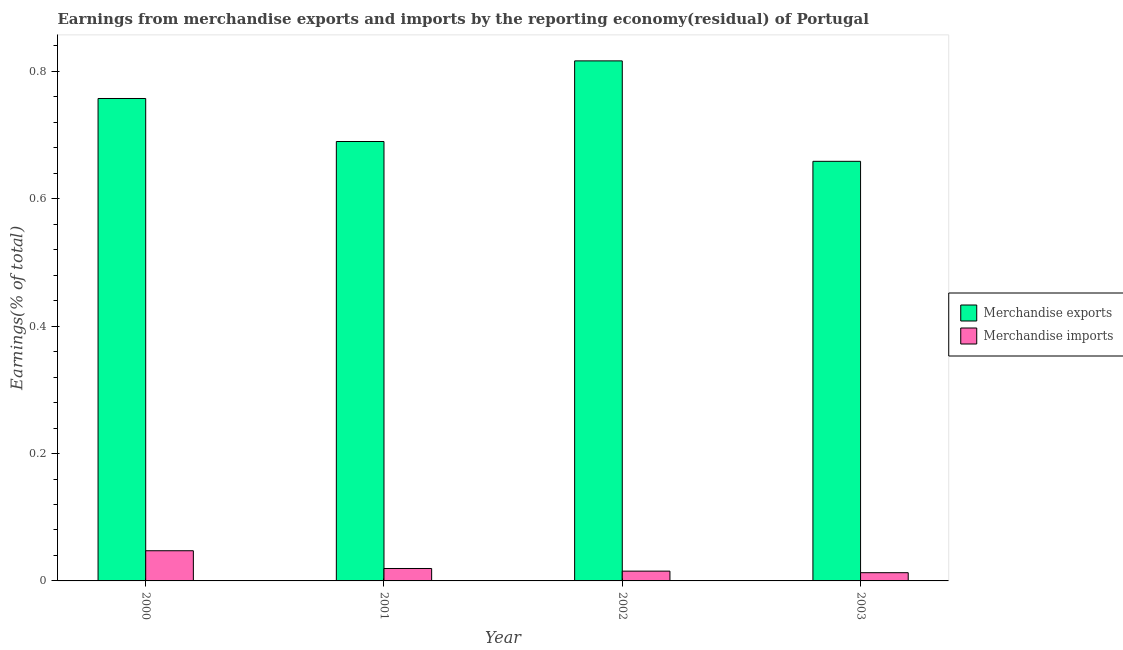How many different coloured bars are there?
Provide a short and direct response. 2. In how many cases, is the number of bars for a given year not equal to the number of legend labels?
Offer a terse response. 0. What is the earnings from merchandise exports in 2001?
Ensure brevity in your answer.  0.69. Across all years, what is the maximum earnings from merchandise exports?
Your answer should be very brief. 0.82. Across all years, what is the minimum earnings from merchandise exports?
Your response must be concise. 0.66. In which year was the earnings from merchandise imports maximum?
Ensure brevity in your answer.  2000. What is the total earnings from merchandise exports in the graph?
Offer a terse response. 2.92. What is the difference between the earnings from merchandise exports in 2000 and that in 2001?
Provide a succinct answer. 0.07. What is the difference between the earnings from merchandise exports in 2003 and the earnings from merchandise imports in 2002?
Give a very brief answer. -0.16. What is the average earnings from merchandise imports per year?
Keep it short and to the point. 0.02. In the year 2002, what is the difference between the earnings from merchandise imports and earnings from merchandise exports?
Offer a very short reply. 0. What is the ratio of the earnings from merchandise exports in 2000 to that in 2002?
Ensure brevity in your answer.  0.93. Is the earnings from merchandise imports in 2002 less than that in 2003?
Offer a very short reply. No. Is the difference between the earnings from merchandise exports in 2001 and 2002 greater than the difference between the earnings from merchandise imports in 2001 and 2002?
Make the answer very short. No. What is the difference between the highest and the second highest earnings from merchandise exports?
Provide a succinct answer. 0.06. What is the difference between the highest and the lowest earnings from merchandise exports?
Ensure brevity in your answer.  0.16. Is the sum of the earnings from merchandise imports in 2000 and 2001 greater than the maximum earnings from merchandise exports across all years?
Offer a terse response. Yes. What does the 2nd bar from the right in 2001 represents?
Your answer should be very brief. Merchandise exports. How are the legend labels stacked?
Provide a succinct answer. Vertical. What is the title of the graph?
Give a very brief answer. Earnings from merchandise exports and imports by the reporting economy(residual) of Portugal. Does "Passenger Transport Items" appear as one of the legend labels in the graph?
Ensure brevity in your answer.  No. What is the label or title of the X-axis?
Offer a very short reply. Year. What is the label or title of the Y-axis?
Make the answer very short. Earnings(% of total). What is the Earnings(% of total) in Merchandise exports in 2000?
Offer a very short reply. 0.76. What is the Earnings(% of total) of Merchandise imports in 2000?
Provide a short and direct response. 0.05. What is the Earnings(% of total) of Merchandise exports in 2001?
Your answer should be very brief. 0.69. What is the Earnings(% of total) of Merchandise imports in 2001?
Offer a terse response. 0.02. What is the Earnings(% of total) in Merchandise exports in 2002?
Ensure brevity in your answer.  0.82. What is the Earnings(% of total) in Merchandise imports in 2002?
Keep it short and to the point. 0.02. What is the Earnings(% of total) of Merchandise exports in 2003?
Provide a short and direct response. 0.66. What is the Earnings(% of total) in Merchandise imports in 2003?
Ensure brevity in your answer.  0.01. Across all years, what is the maximum Earnings(% of total) in Merchandise exports?
Your answer should be compact. 0.82. Across all years, what is the maximum Earnings(% of total) of Merchandise imports?
Keep it short and to the point. 0.05. Across all years, what is the minimum Earnings(% of total) in Merchandise exports?
Offer a terse response. 0.66. Across all years, what is the minimum Earnings(% of total) in Merchandise imports?
Give a very brief answer. 0.01. What is the total Earnings(% of total) in Merchandise exports in the graph?
Offer a terse response. 2.92. What is the total Earnings(% of total) of Merchandise imports in the graph?
Your response must be concise. 0.1. What is the difference between the Earnings(% of total) of Merchandise exports in 2000 and that in 2001?
Your answer should be compact. 0.07. What is the difference between the Earnings(% of total) of Merchandise imports in 2000 and that in 2001?
Your answer should be compact. 0.03. What is the difference between the Earnings(% of total) in Merchandise exports in 2000 and that in 2002?
Your answer should be compact. -0.06. What is the difference between the Earnings(% of total) in Merchandise imports in 2000 and that in 2002?
Offer a very short reply. 0.03. What is the difference between the Earnings(% of total) of Merchandise exports in 2000 and that in 2003?
Your answer should be very brief. 0.1. What is the difference between the Earnings(% of total) of Merchandise imports in 2000 and that in 2003?
Provide a succinct answer. 0.03. What is the difference between the Earnings(% of total) in Merchandise exports in 2001 and that in 2002?
Make the answer very short. -0.13. What is the difference between the Earnings(% of total) in Merchandise imports in 2001 and that in 2002?
Provide a succinct answer. 0. What is the difference between the Earnings(% of total) in Merchandise exports in 2001 and that in 2003?
Offer a terse response. 0.03. What is the difference between the Earnings(% of total) in Merchandise imports in 2001 and that in 2003?
Your answer should be very brief. 0.01. What is the difference between the Earnings(% of total) in Merchandise exports in 2002 and that in 2003?
Offer a terse response. 0.16. What is the difference between the Earnings(% of total) in Merchandise imports in 2002 and that in 2003?
Your response must be concise. 0. What is the difference between the Earnings(% of total) in Merchandise exports in 2000 and the Earnings(% of total) in Merchandise imports in 2001?
Offer a very short reply. 0.74. What is the difference between the Earnings(% of total) of Merchandise exports in 2000 and the Earnings(% of total) of Merchandise imports in 2002?
Your answer should be compact. 0.74. What is the difference between the Earnings(% of total) of Merchandise exports in 2000 and the Earnings(% of total) of Merchandise imports in 2003?
Your answer should be very brief. 0.74. What is the difference between the Earnings(% of total) of Merchandise exports in 2001 and the Earnings(% of total) of Merchandise imports in 2002?
Provide a succinct answer. 0.67. What is the difference between the Earnings(% of total) of Merchandise exports in 2001 and the Earnings(% of total) of Merchandise imports in 2003?
Your answer should be compact. 0.68. What is the difference between the Earnings(% of total) of Merchandise exports in 2002 and the Earnings(% of total) of Merchandise imports in 2003?
Keep it short and to the point. 0.8. What is the average Earnings(% of total) of Merchandise exports per year?
Offer a terse response. 0.73. What is the average Earnings(% of total) in Merchandise imports per year?
Provide a succinct answer. 0.02. In the year 2000, what is the difference between the Earnings(% of total) of Merchandise exports and Earnings(% of total) of Merchandise imports?
Make the answer very short. 0.71. In the year 2001, what is the difference between the Earnings(% of total) in Merchandise exports and Earnings(% of total) in Merchandise imports?
Give a very brief answer. 0.67. In the year 2002, what is the difference between the Earnings(% of total) in Merchandise exports and Earnings(% of total) in Merchandise imports?
Offer a terse response. 0.8. In the year 2003, what is the difference between the Earnings(% of total) of Merchandise exports and Earnings(% of total) of Merchandise imports?
Provide a short and direct response. 0.65. What is the ratio of the Earnings(% of total) of Merchandise exports in 2000 to that in 2001?
Your answer should be compact. 1.1. What is the ratio of the Earnings(% of total) of Merchandise imports in 2000 to that in 2001?
Your response must be concise. 2.43. What is the ratio of the Earnings(% of total) in Merchandise exports in 2000 to that in 2002?
Provide a succinct answer. 0.93. What is the ratio of the Earnings(% of total) of Merchandise imports in 2000 to that in 2002?
Your answer should be compact. 3.08. What is the ratio of the Earnings(% of total) in Merchandise exports in 2000 to that in 2003?
Offer a terse response. 1.15. What is the ratio of the Earnings(% of total) of Merchandise imports in 2000 to that in 2003?
Provide a succinct answer. 3.67. What is the ratio of the Earnings(% of total) in Merchandise exports in 2001 to that in 2002?
Provide a short and direct response. 0.84. What is the ratio of the Earnings(% of total) of Merchandise imports in 2001 to that in 2002?
Provide a short and direct response. 1.27. What is the ratio of the Earnings(% of total) of Merchandise exports in 2001 to that in 2003?
Your response must be concise. 1.05. What is the ratio of the Earnings(% of total) of Merchandise imports in 2001 to that in 2003?
Your answer should be compact. 1.51. What is the ratio of the Earnings(% of total) of Merchandise exports in 2002 to that in 2003?
Give a very brief answer. 1.24. What is the ratio of the Earnings(% of total) of Merchandise imports in 2002 to that in 2003?
Offer a terse response. 1.19. What is the difference between the highest and the second highest Earnings(% of total) in Merchandise exports?
Your answer should be very brief. 0.06. What is the difference between the highest and the second highest Earnings(% of total) in Merchandise imports?
Offer a very short reply. 0.03. What is the difference between the highest and the lowest Earnings(% of total) of Merchandise exports?
Ensure brevity in your answer.  0.16. What is the difference between the highest and the lowest Earnings(% of total) of Merchandise imports?
Make the answer very short. 0.03. 